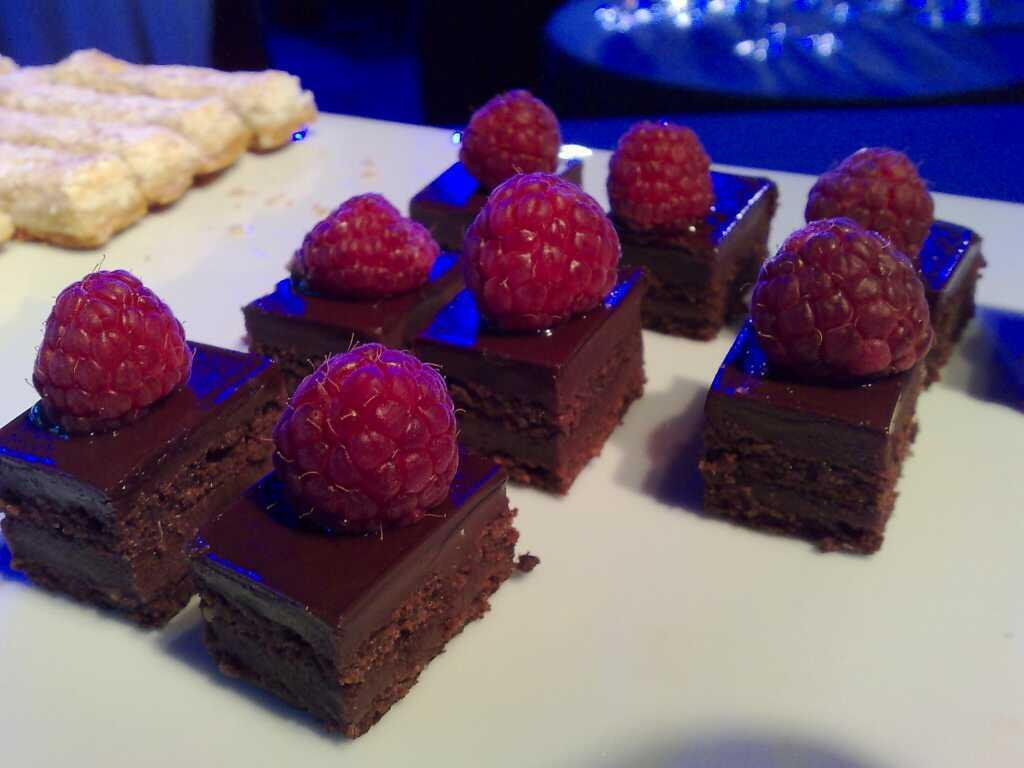What type of furniture is visible in the image? There is a table in the image. What is placed on the table? There are pieces of cake and other food on the table. Can you describe the decoration on the pieces of cake? Berries are present on the pieces of cake. What type of shirt is the cake wearing in the image? The cake is not wearing a shirt, as it is a dessert and not a person. 